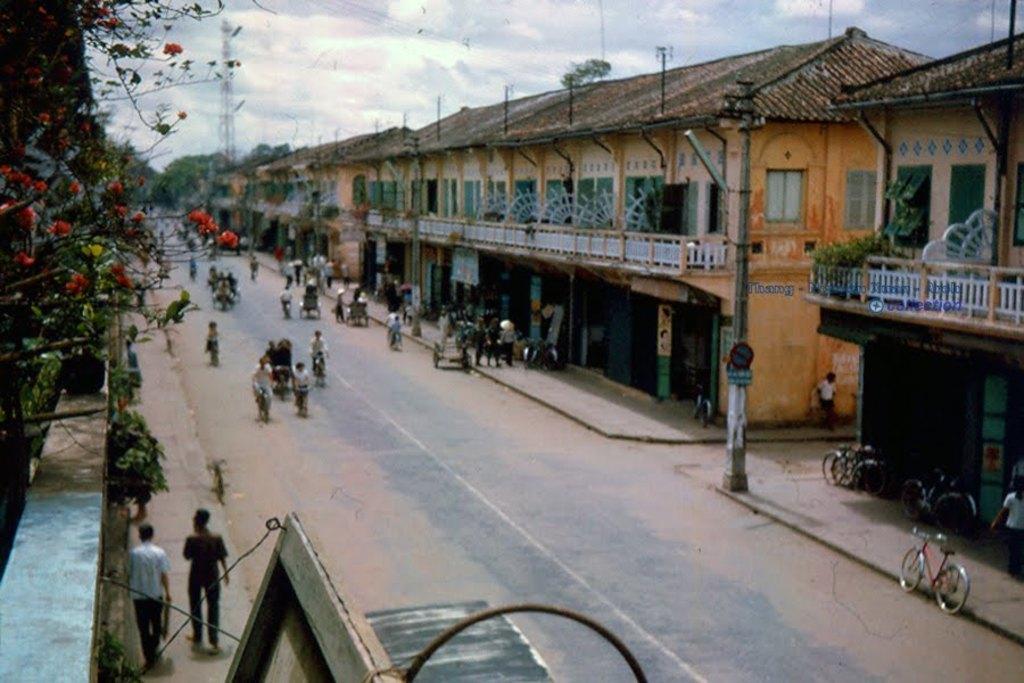Could you give a brief overview of what you see in this image? In this image I can see a road , on the road I can see few persons walking and few persons riding on vehicles and a pole visible in the middle in front of the building visible on the right side , on the left side there is wall ,trees, flowers visible and there are few bicycles visible in front of building on the right side. 